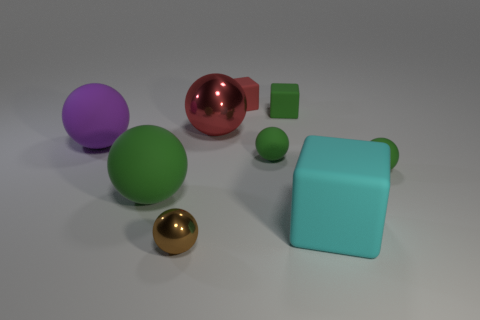What number of things are either small cyan cubes or green matte spheres?
Keep it short and to the point. 3. Is there a purple object behind the large object that is in front of the big green matte sphere?
Your answer should be very brief. Yes. Are there more big green rubber balls that are in front of the red shiny sphere than objects that are left of the big purple object?
Offer a terse response. Yes. What material is the tiny block that is the same color as the big metallic sphere?
Provide a short and direct response. Rubber. How many matte spheres are the same color as the big metal object?
Your response must be concise. 0. There is a rubber thing on the left side of the large green rubber sphere; is it the same color as the small object to the left of the tiny red object?
Give a very brief answer. No. Are there any brown balls in front of the red rubber thing?
Provide a short and direct response. Yes. What material is the large green sphere?
Give a very brief answer. Rubber. There is a green object that is behind the purple object; what shape is it?
Give a very brief answer. Cube. The rubber thing that is the same color as the large metal ball is what size?
Provide a succinct answer. Small. 